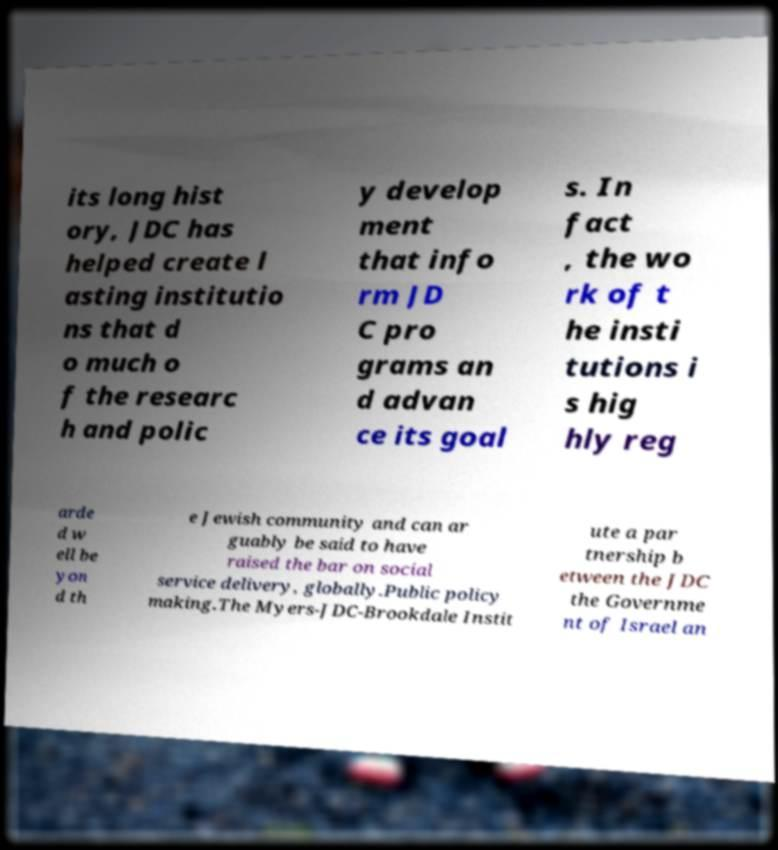What messages or text are displayed in this image? I need them in a readable, typed format. its long hist ory, JDC has helped create l asting institutio ns that d o much o f the researc h and polic y develop ment that info rm JD C pro grams an d advan ce its goal s. In fact , the wo rk of t he insti tutions i s hig hly reg arde d w ell be yon d th e Jewish community and can ar guably be said to have raised the bar on social service delivery, globally.Public policy making.The Myers-JDC-Brookdale Instit ute a par tnership b etween the JDC the Governme nt of Israel an 